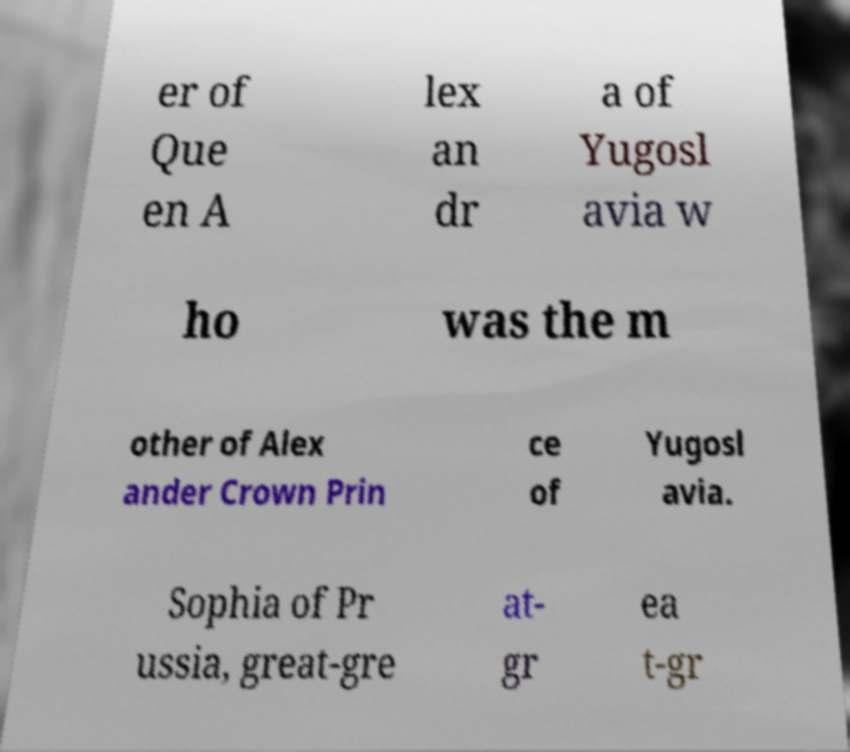What messages or text are displayed in this image? I need them in a readable, typed format. er of Que en A lex an dr a of Yugosl avia w ho was the m other of Alex ander Crown Prin ce of Yugosl avia. Sophia of Pr ussia, great-gre at- gr ea t-gr 